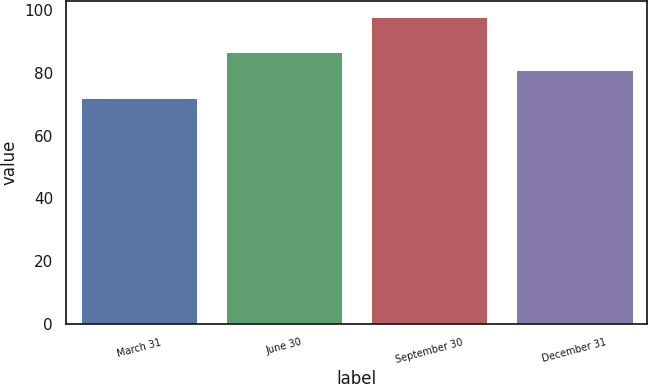Convert chart to OTSL. <chart><loc_0><loc_0><loc_500><loc_500><bar_chart><fcel>March 31<fcel>June 30<fcel>September 30<fcel>December 31<nl><fcel>72.2<fcel>86.73<fcel>98.02<fcel>81.12<nl></chart> 